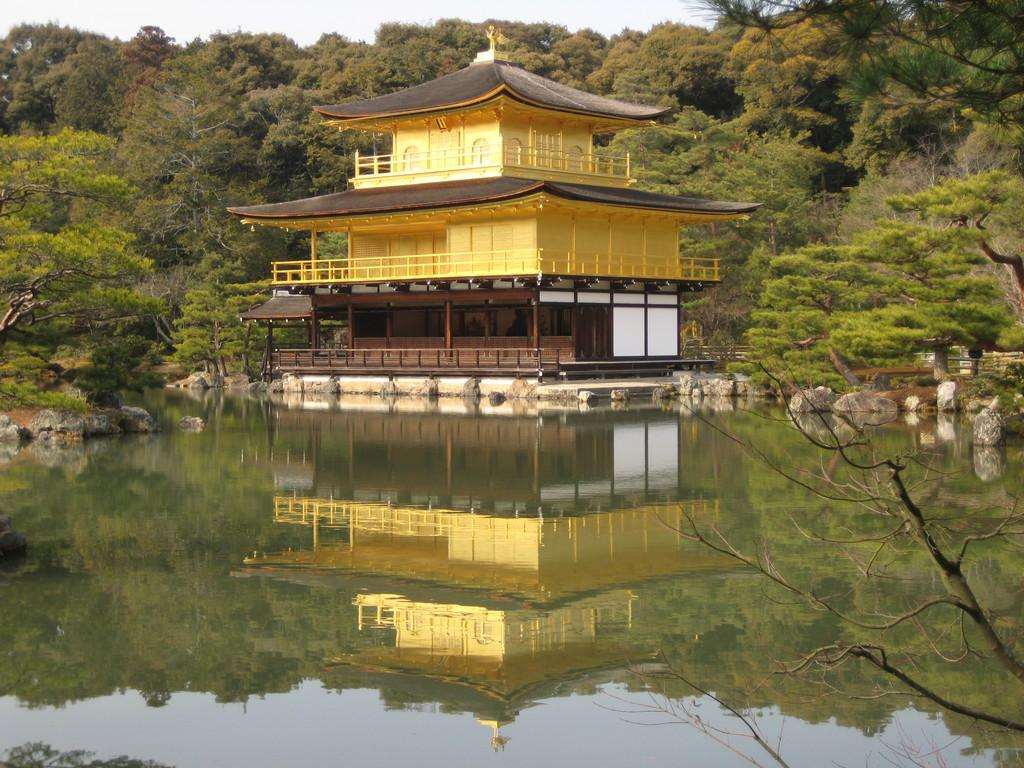What is the main subject of the image? The main subject of the image is a building in a water body. What can be seen around the building? There are stones around the place in the image. What is visible in the background of the image? There are trees in the background of the image. How is the sky depicted in the image? The sky is clear in the image. What type of lumber is being used to construct the building in the image? There is no indication of the building's construction materials in the image, so it cannot be determined from the image. Can you see a bear in the image? No, there is no bear present in the image. 